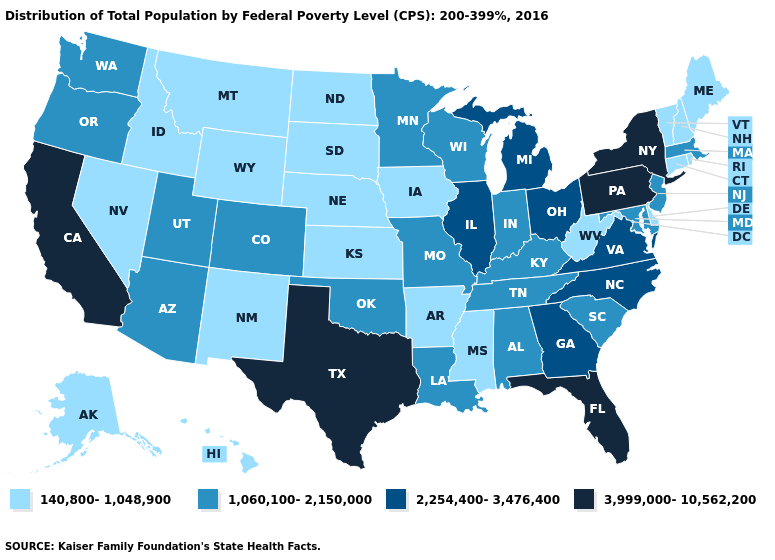Which states have the highest value in the USA?
Write a very short answer. California, Florida, New York, Pennsylvania, Texas. Does Florida have the highest value in the USA?
Quick response, please. Yes. How many symbols are there in the legend?
Be succinct. 4. Name the states that have a value in the range 140,800-1,048,900?
Concise answer only. Alaska, Arkansas, Connecticut, Delaware, Hawaii, Idaho, Iowa, Kansas, Maine, Mississippi, Montana, Nebraska, Nevada, New Hampshire, New Mexico, North Dakota, Rhode Island, South Dakota, Vermont, West Virginia, Wyoming. Does Missouri have the lowest value in the MidWest?
Give a very brief answer. No. Name the states that have a value in the range 3,999,000-10,562,200?
Write a very short answer. California, Florida, New York, Pennsylvania, Texas. Name the states that have a value in the range 3,999,000-10,562,200?
Write a very short answer. California, Florida, New York, Pennsylvania, Texas. Which states hav the highest value in the West?
Quick response, please. California. Name the states that have a value in the range 2,254,400-3,476,400?
Short answer required. Georgia, Illinois, Michigan, North Carolina, Ohio, Virginia. What is the value of Oklahoma?
Give a very brief answer. 1,060,100-2,150,000. Name the states that have a value in the range 1,060,100-2,150,000?
Answer briefly. Alabama, Arizona, Colorado, Indiana, Kentucky, Louisiana, Maryland, Massachusetts, Minnesota, Missouri, New Jersey, Oklahoma, Oregon, South Carolina, Tennessee, Utah, Washington, Wisconsin. What is the lowest value in the USA?
Answer briefly. 140,800-1,048,900. Does New York have the highest value in the USA?
Keep it brief. Yes. Does Kentucky have the same value as North Carolina?
Answer briefly. No. Which states have the lowest value in the South?
Short answer required. Arkansas, Delaware, Mississippi, West Virginia. 